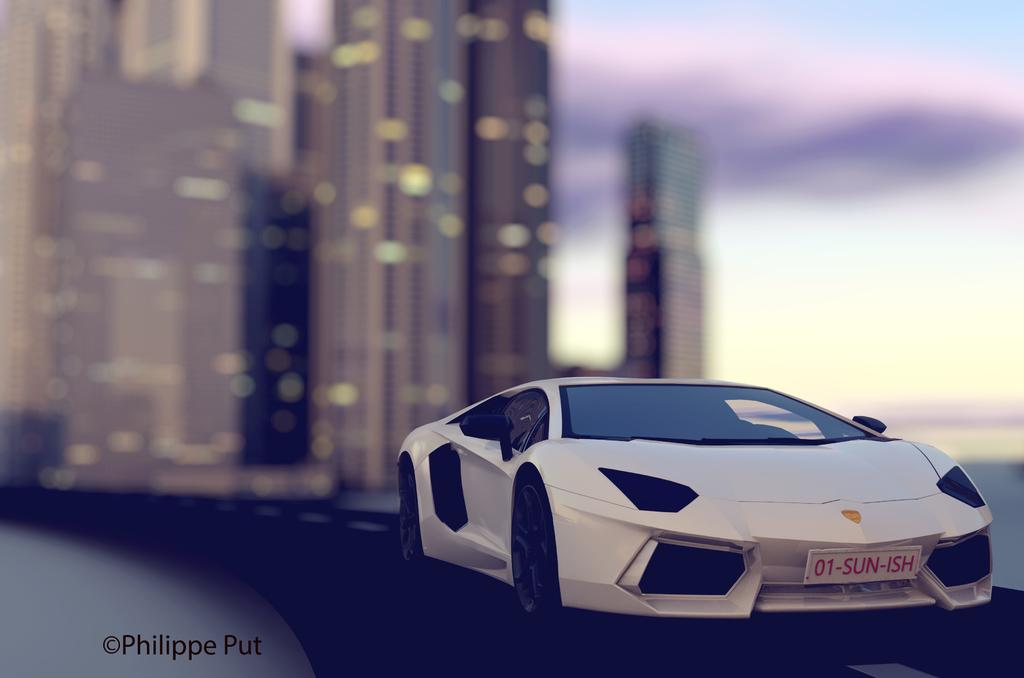What can be observed about the image itself? The image is edited. What is the main object in the foreground of the image? There is a toy car in the foreground. How is the background of the toy car depicted in the image? The background of the toy car is blurred. Where can a name or label be found in the image? There is a name at the bottom left corner of the image. What type of property is being sold in the image? There is no property being sold in the image; it features a toy car with a blurred background. Can you tell me how many tramps are visible in the image? There are no tramps present in the image. 